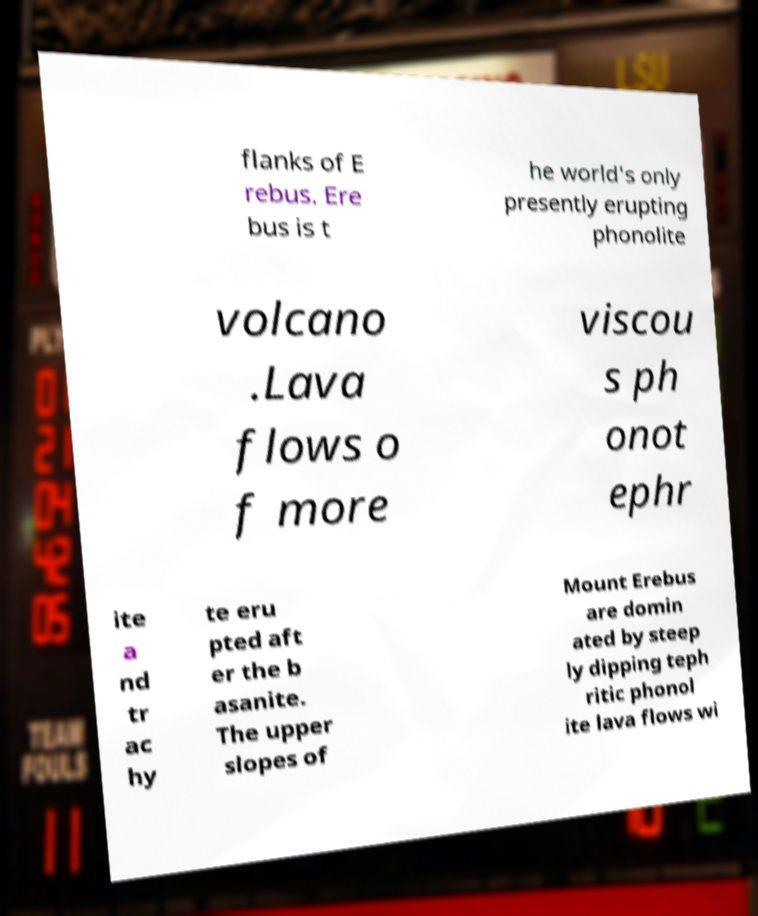Can you accurately transcribe the text from the provided image for me? flanks of E rebus. Ere bus is t he world's only presently erupting phonolite volcano .Lava flows o f more viscou s ph onot ephr ite a nd tr ac hy te eru pted aft er the b asanite. The upper slopes of Mount Erebus are domin ated by steep ly dipping teph ritic phonol ite lava flows wi 